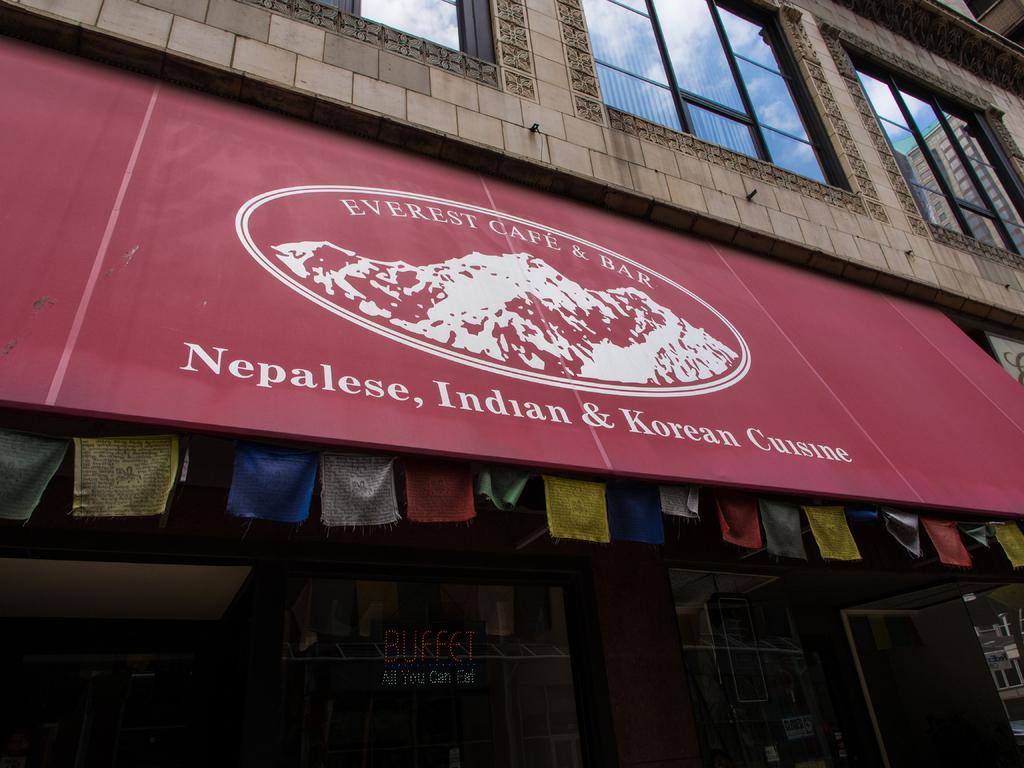Describe this image in one or two sentences. In the foreground of this image, there is a building and in the middle, there is a red colored board and text on it and there are clothes hanging behind it. On the top, there are glass windows and on the bottom, there is glass and a text on it. 